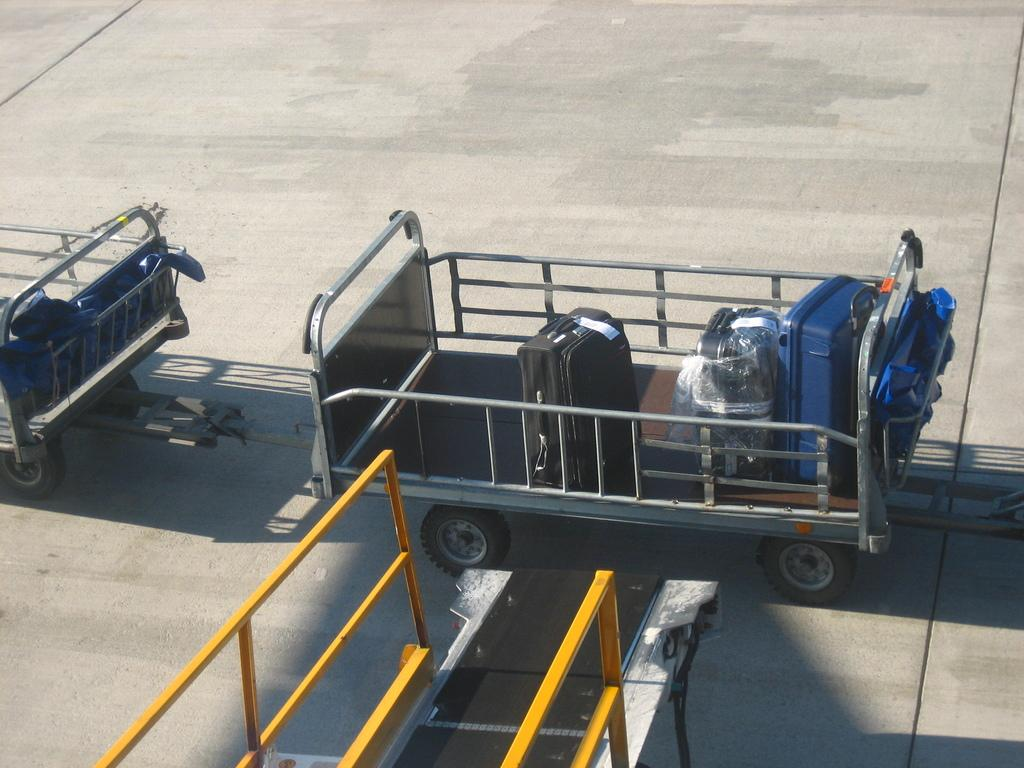What is the main subject of the picture? The main subject of the picture is a trolley. Are there any additional trolleys connected to the main trolley? Yes, there are multiple trolleys connected to the main trolley. What is placed on the trolley? There are suitcases placed on the trolley. Where is the sink located in the image? There is no sink present in the image; it features a trolley with multiple connected trolleys and suitcases. What type of bead is used to decorate the trolley in the image? There are no beads present on the trolley in the image. 